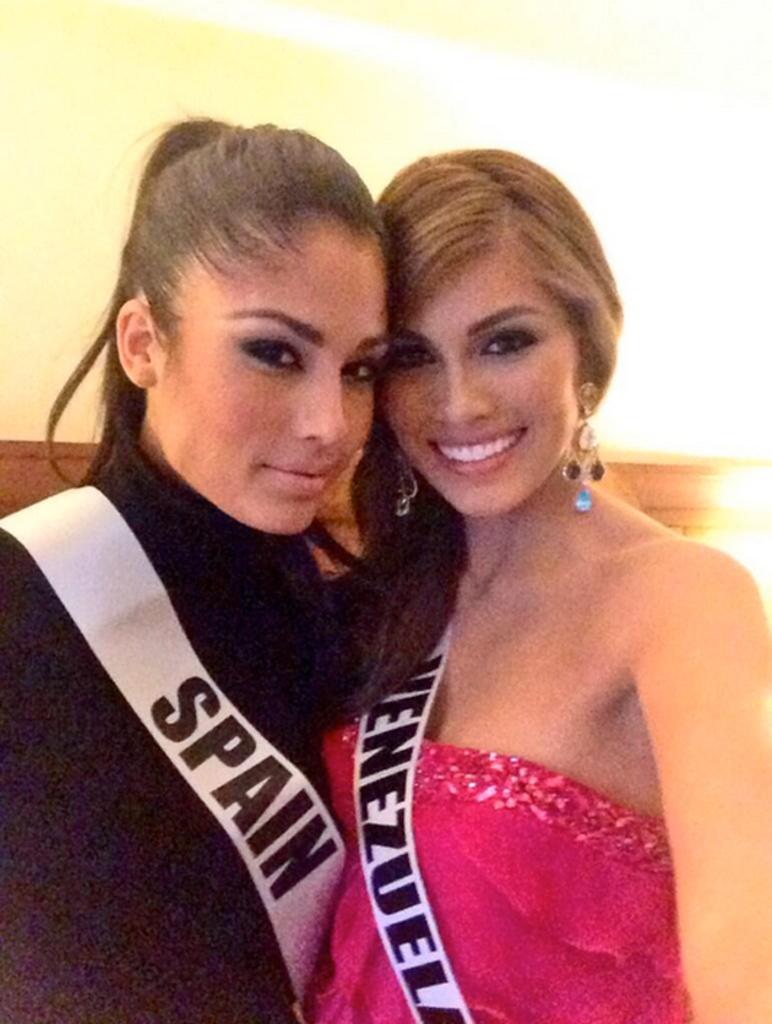What country is the person on the left representing?
Ensure brevity in your answer.  Spain. What country does the contestant from the right come from?
Provide a succinct answer. Venezuela. 